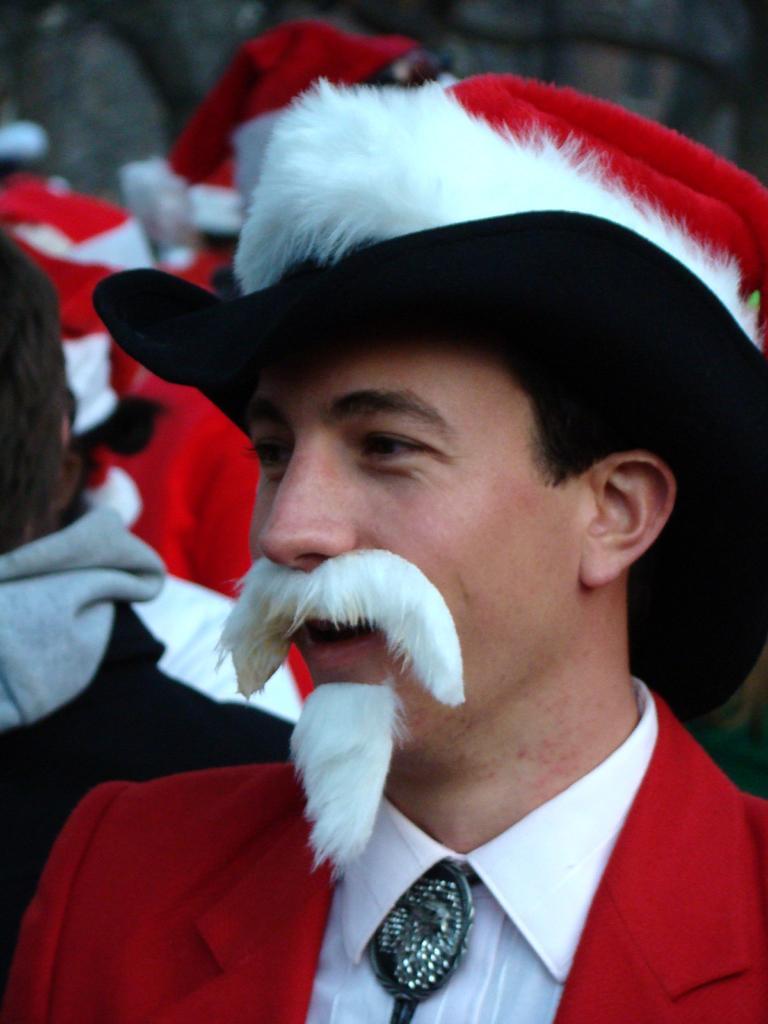Please provide a concise description of this image. In this image I can see a person wearing white shirt, red jacket and white, red and black colored hat. I can see he is wearing white colored mustache and beard. In the background I can see few other persons. 